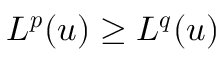Convert formula to latex. <formula><loc_0><loc_0><loc_500><loc_500>L ^ { p } ( u ) \geq L ^ { q } ( u )</formula> 